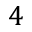Convert formula to latex. <formula><loc_0><loc_0><loc_500><loc_500>4</formula> 